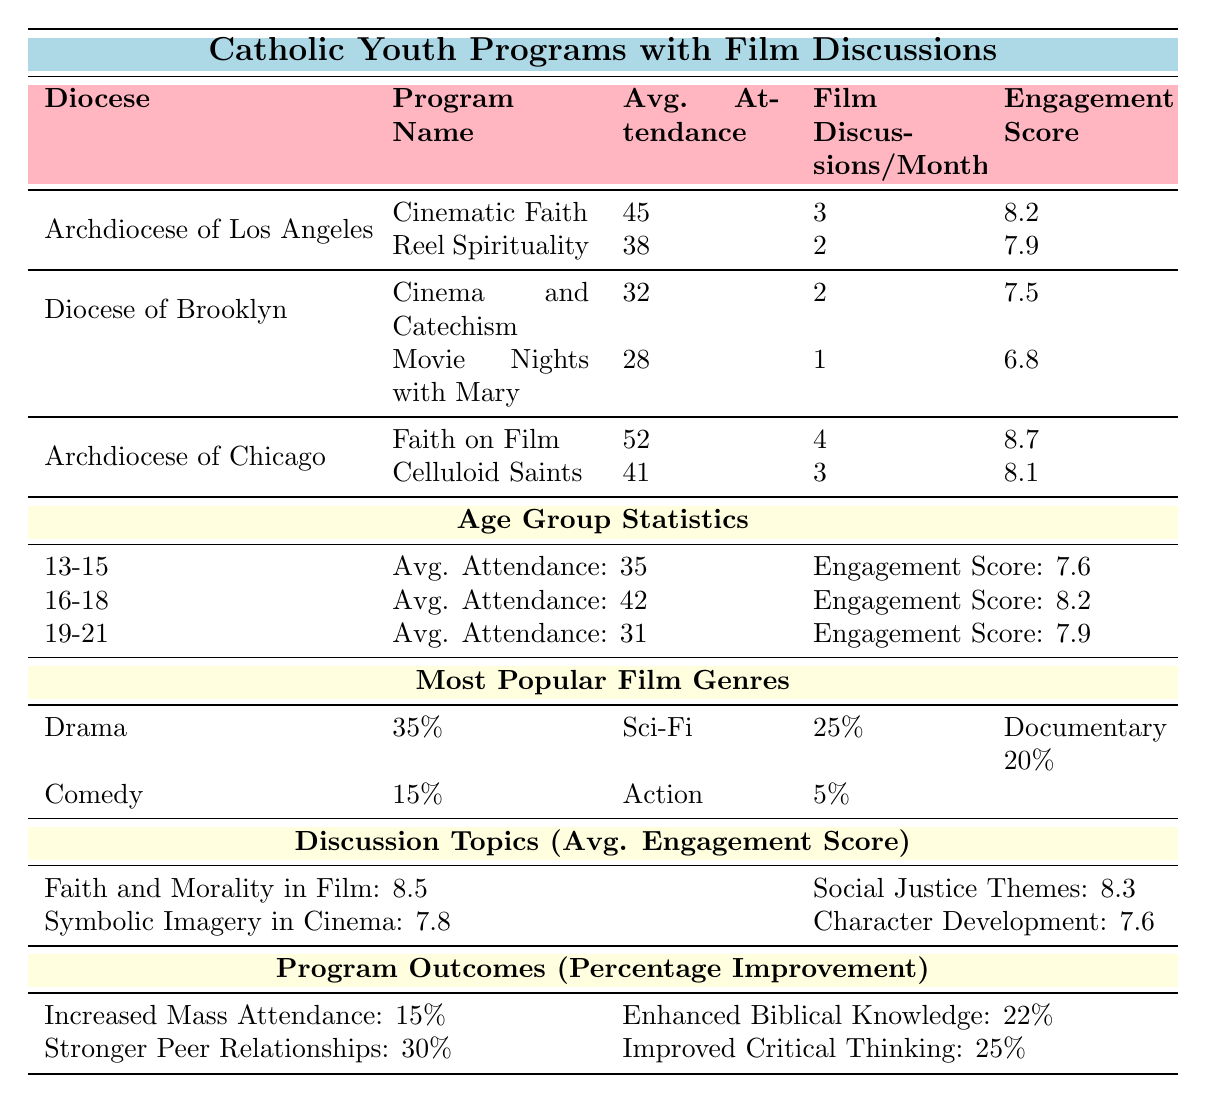What is the average attendance for the program "Cinematic Faith"? The table states that the average attendance for "Cinematic Faith" is listed in the row corresponding to the Archdiocese of Los Angeles under that program's details. It shows 45.
Answer: 45 Which age group has the highest average attendance? By inspecting the Age Group Statistics section, the average attendance values for each group are 35 for 13-15, 42 for 16-18, and 31 for 19-21. The highest value is 42 for the 16-18 age group.
Answer: 16-18 What is the engagement score for the program "Faith on Film"? The engagement score for "Faith on Film" is located in the row that corresponds to this program under the Archdiocese of Chicago section, which states 8.7.
Answer: 8.7 How many film discussions per month does "Movie Nights with Mary" have? Looking under the Diocese of Brooklyn section, the row for "Movie Nights with Mary" indicates that it has 1 film discussion per month.
Answer: 1 What is the average engagement score across all age groups? The engagement scores for the age groups are 7.6 (13-15), 8.2 (16-18), and 7.9 (19-21). To find the average: (7.6 + 8.2 + 7.9) / 3 = 7.866, which can be rounded to 7.87.
Answer: 7.87 Is the engagement score for "Reel Spirituality" higher than 8.0? The engagement score listed for "Reel Spirituality" under the Archdiocese of Los Angeles is 7.9, which is less than 8.0. Therefore, the answer is no.
Answer: No Which discussion topic has the highest average engagement score? Referring to the Discussion Topics section, the scores for the topics are: Faith and Morality in Film (8.5), Social Justice Themes (8.3), Symbolic Imagery in Cinema (7.8), and Character Development and Virtues (7.6). The highest score is 8.5 for "Faith and Morality in Film."
Answer: Faith and Morality in Film What percentage improvement is reported for "Stronger Peer Relationships"? In the Program Outcomes section, the row for "Stronger Peer Relationships" states a percentage improvement of 30%.
Answer: 30% If the Archdiocese of Chicago has two programs, what is their combined average attendance? The average attendances for the programs under Archdiocese of Chicago are 52 for "Faith on Film" and 41 for "Celluloid Saints." To find the combined average: (52 + 41) / 2 = 46.5.
Answer: 46.5 Which film genre is less preferred than Comedy? The table indicates the percentages for different genres: Drama (35%), Science Fiction (25%), Documentary (20%), Comedy (15%), and Action (5%). Science Fiction, Documentary, and Action are all less preferred than Comedy. However, Action has the lowest preference at 5%.
Answer: Action 